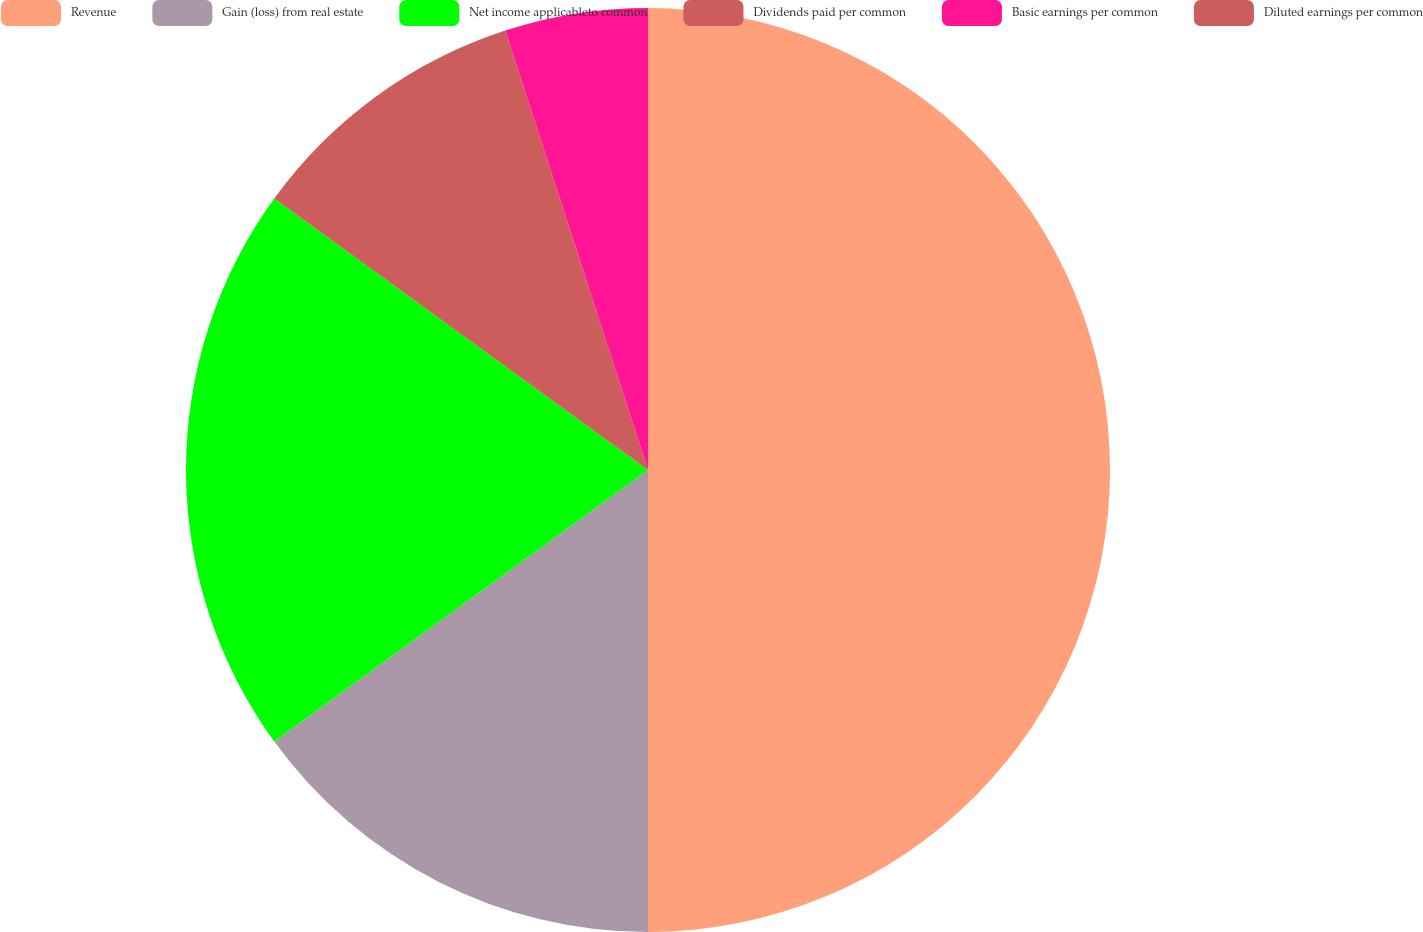Convert chart to OTSL. <chart><loc_0><loc_0><loc_500><loc_500><pie_chart><fcel>Revenue<fcel>Gain (loss) from real estate<fcel>Net income applicableto common<fcel>Dividends paid per common<fcel>Basic earnings per common<fcel>Diluted earnings per common<nl><fcel>50.0%<fcel>15.0%<fcel>20.0%<fcel>10.0%<fcel>5.0%<fcel>0.0%<nl></chart> 